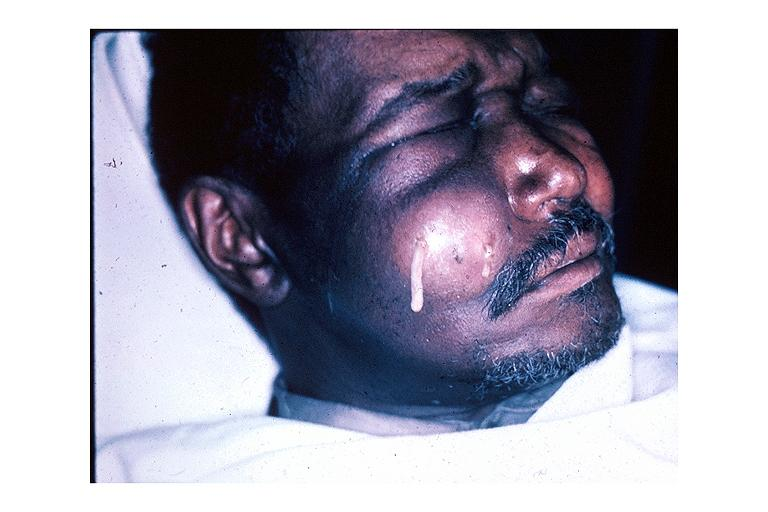s anomalous origin present?
Answer the question using a single word or phrase. No 